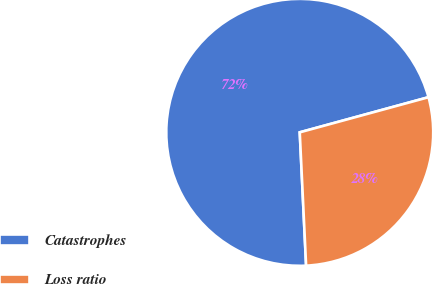Convert chart. <chart><loc_0><loc_0><loc_500><loc_500><pie_chart><fcel>Catastrophes<fcel>Loss ratio<nl><fcel>71.52%<fcel>28.48%<nl></chart> 